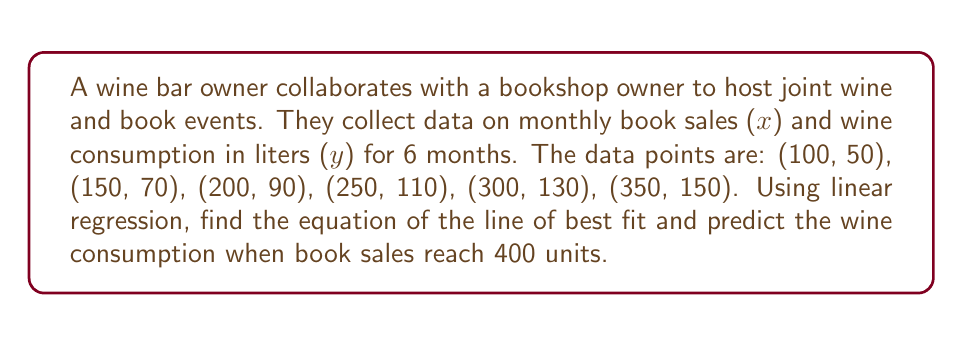Can you solve this math problem? 1. To find the line of best fit using linear regression, we use the equation:
   $y = mx + b$
   where $m$ is the slope and $b$ is the y-intercept.

2. Calculate the means of x and y:
   $\bar{x} = \frac{100 + 150 + 200 + 250 + 300 + 350}{6} = 225$
   $\bar{y} = \frac{50 + 70 + 90 + 110 + 130 + 150}{6} = 100$

3. Calculate the slope $m$ using the formula:
   $m = \frac{\sum(x_i - \bar{x})(y_i - \bar{y})}{\sum(x_i - \bar{x})^2}$

4. Compute the numerator and denominator:
   Numerator: $(-125)(-50) + (-75)(-30) + (-25)(-10) + (25)(10) + (75)(30) + (125)(50) = 31250$
   Denominator: $(-125)^2 + (-75)^2 + (-25)^2 + (25)^2 + (75)^2 + (125)^2 = 62500$

5. Calculate $m$:
   $m = \frac{31250}{62500} = 0.5$

6. Find $b$ using the equation: $b = \bar{y} - m\bar{x}$
   $b = 100 - 0.5(225) = -12.5$

7. The equation of the line of best fit is:
   $y = 0.5x - 12.5$

8. To predict wine consumption when book sales are 400:
   $y = 0.5(400) - 12.5 = 187.5$
Answer: $y = 0.5x - 12.5$; 187.5 liters 